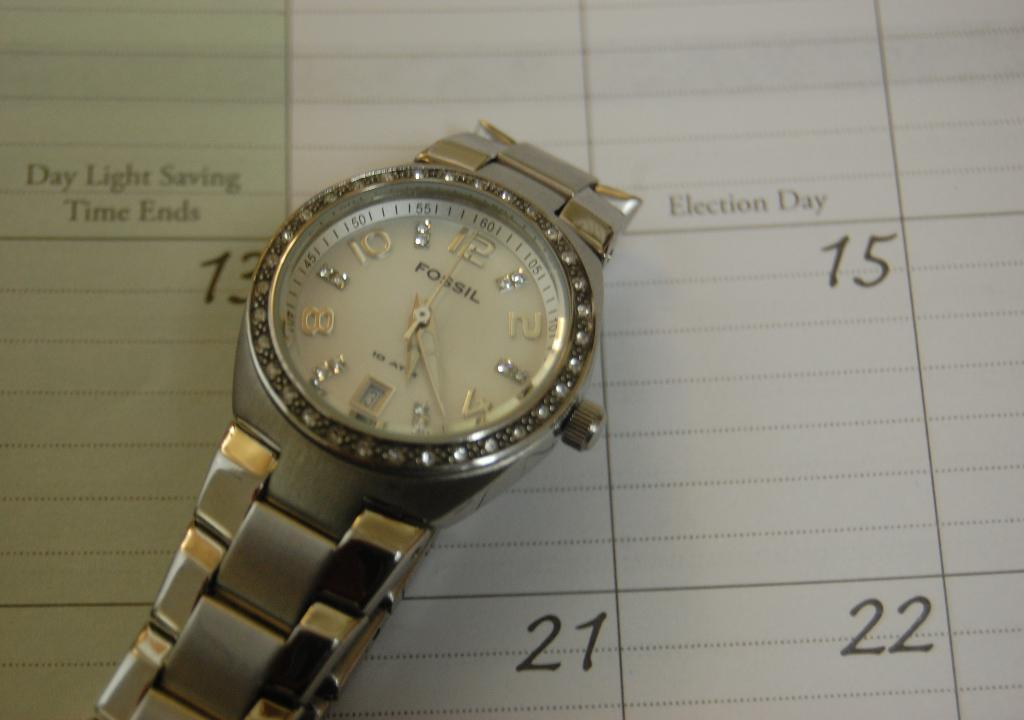<image>
Render a clear and concise summary of the photo. Fossil women's metallic watch with jeweled dashes between even numbered embossed numerals, edging with steel buttons all along outer perimeter. 